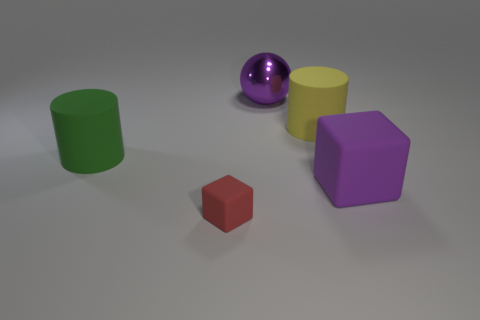Add 4 tiny yellow metal things. How many objects exist? 9 Subtract all green cylinders. How many cylinders are left? 1 Subtract all spheres. How many objects are left? 4 Subtract 1 cubes. How many cubes are left? 1 Add 2 large cylinders. How many large cylinders are left? 4 Add 5 big brown matte things. How many big brown matte things exist? 5 Subtract 0 blue cylinders. How many objects are left? 5 Subtract all purple blocks. Subtract all purple spheres. How many blocks are left? 1 Subtract all blue cylinders. How many red blocks are left? 1 Subtract all cyan metallic objects. Subtract all large purple matte blocks. How many objects are left? 4 